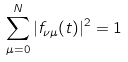Convert formula to latex. <formula><loc_0><loc_0><loc_500><loc_500>\sum _ { \mu = 0 } ^ { N } | f _ { \nu \mu } ( t ) | ^ { 2 } = 1</formula> 